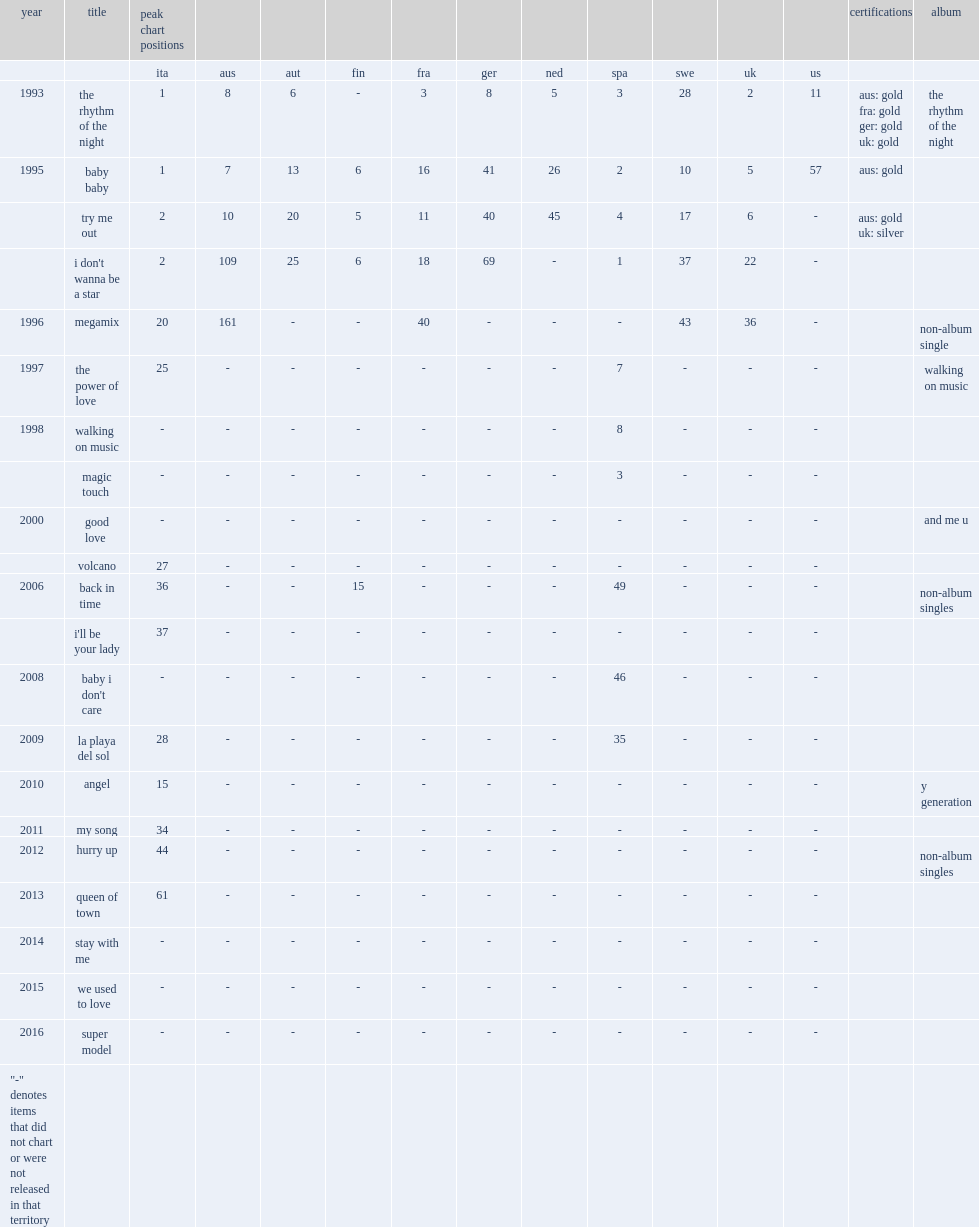What was the name of corona's first single released in 1993? The rhythm of the night. 